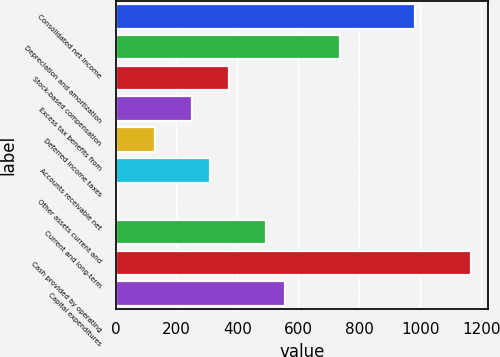Convert chart to OTSL. <chart><loc_0><loc_0><loc_500><loc_500><bar_chart><fcel>Consolidated net income<fcel>Depreciation and amortization<fcel>Stock-based compensation<fcel>Excess tax benefits from<fcel>Deferred income taxes<fcel>Accounts receivable net<fcel>Other assets current and<fcel>Current and long-term<fcel>Cash provided by operating<fcel>Capital expenditures<nl><fcel>982.44<fcel>738.28<fcel>372.04<fcel>249.96<fcel>127.88<fcel>311<fcel>5.8<fcel>494.12<fcel>1165.56<fcel>555.16<nl></chart> 